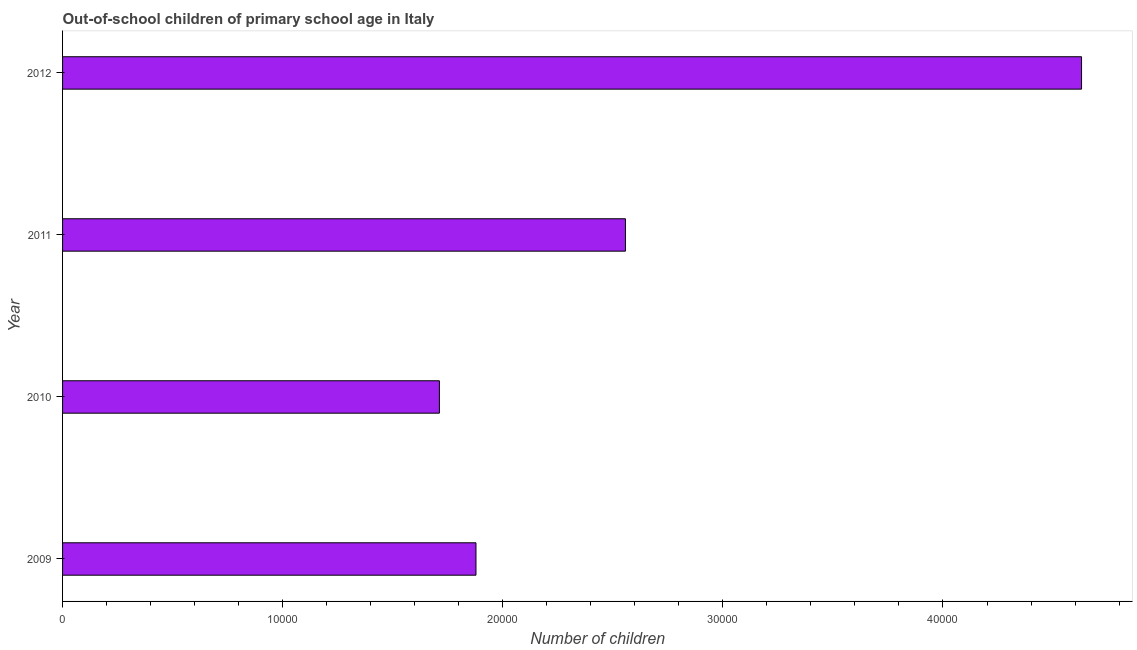Does the graph contain grids?
Your response must be concise. No. What is the title of the graph?
Your answer should be very brief. Out-of-school children of primary school age in Italy. What is the label or title of the X-axis?
Make the answer very short. Number of children. What is the label or title of the Y-axis?
Ensure brevity in your answer.  Year. What is the number of out-of-school children in 2011?
Keep it short and to the point. 2.56e+04. Across all years, what is the maximum number of out-of-school children?
Provide a succinct answer. 4.63e+04. Across all years, what is the minimum number of out-of-school children?
Offer a very short reply. 1.71e+04. What is the sum of the number of out-of-school children?
Your answer should be very brief. 1.08e+05. What is the difference between the number of out-of-school children in 2010 and 2012?
Provide a short and direct response. -2.92e+04. What is the average number of out-of-school children per year?
Provide a short and direct response. 2.69e+04. What is the median number of out-of-school children?
Offer a very short reply. 2.22e+04. Do a majority of the years between 2011 and 2012 (inclusive) have number of out-of-school children greater than 4000 ?
Your answer should be compact. Yes. What is the ratio of the number of out-of-school children in 2009 to that in 2012?
Offer a very short reply. 0.41. Is the number of out-of-school children in 2009 less than that in 2010?
Keep it short and to the point. No. What is the difference between the highest and the second highest number of out-of-school children?
Give a very brief answer. 2.07e+04. What is the difference between the highest and the lowest number of out-of-school children?
Your response must be concise. 2.92e+04. How many bars are there?
Provide a succinct answer. 4. How many years are there in the graph?
Provide a short and direct response. 4. What is the Number of children in 2009?
Your answer should be compact. 1.88e+04. What is the Number of children in 2010?
Provide a short and direct response. 1.71e+04. What is the Number of children of 2011?
Offer a very short reply. 2.56e+04. What is the Number of children in 2012?
Offer a terse response. 4.63e+04. What is the difference between the Number of children in 2009 and 2010?
Keep it short and to the point. 1661. What is the difference between the Number of children in 2009 and 2011?
Offer a very short reply. -6791. What is the difference between the Number of children in 2009 and 2012?
Provide a short and direct response. -2.75e+04. What is the difference between the Number of children in 2010 and 2011?
Provide a short and direct response. -8452. What is the difference between the Number of children in 2010 and 2012?
Your answer should be very brief. -2.92e+04. What is the difference between the Number of children in 2011 and 2012?
Provide a succinct answer. -2.07e+04. What is the ratio of the Number of children in 2009 to that in 2010?
Your answer should be very brief. 1.1. What is the ratio of the Number of children in 2009 to that in 2011?
Make the answer very short. 0.73. What is the ratio of the Number of children in 2009 to that in 2012?
Provide a succinct answer. 0.41. What is the ratio of the Number of children in 2010 to that in 2011?
Your answer should be compact. 0.67. What is the ratio of the Number of children in 2010 to that in 2012?
Make the answer very short. 0.37. What is the ratio of the Number of children in 2011 to that in 2012?
Keep it short and to the point. 0.55. 